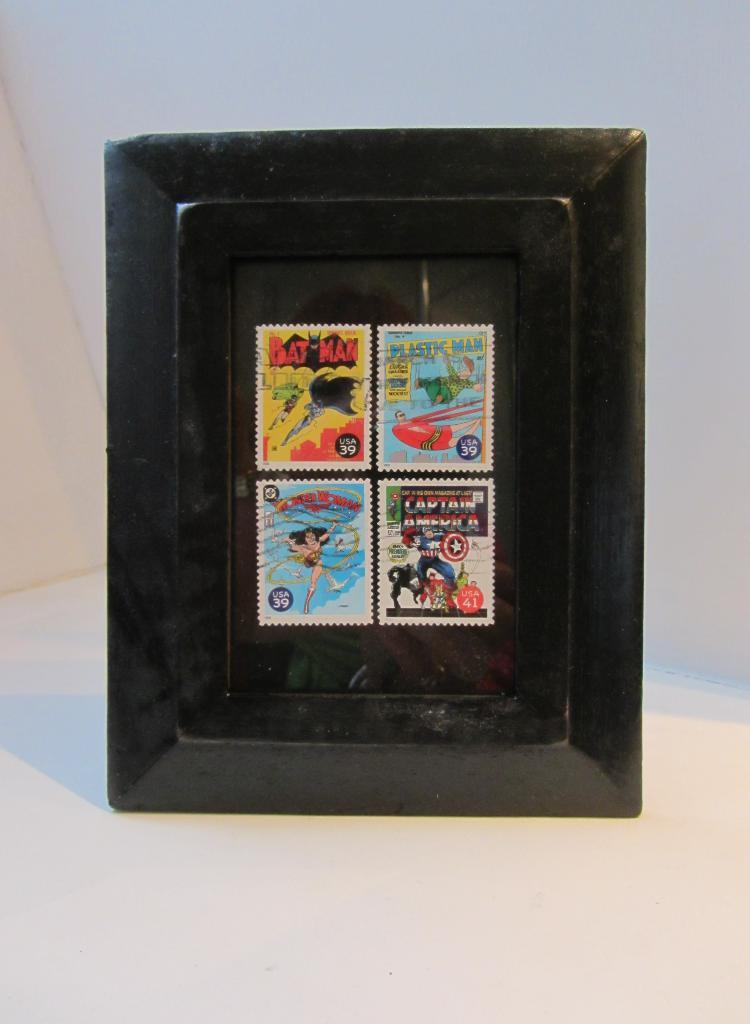<image>
Describe the image concisely. Four framed comic book stamps, including Batman and Captain America. 